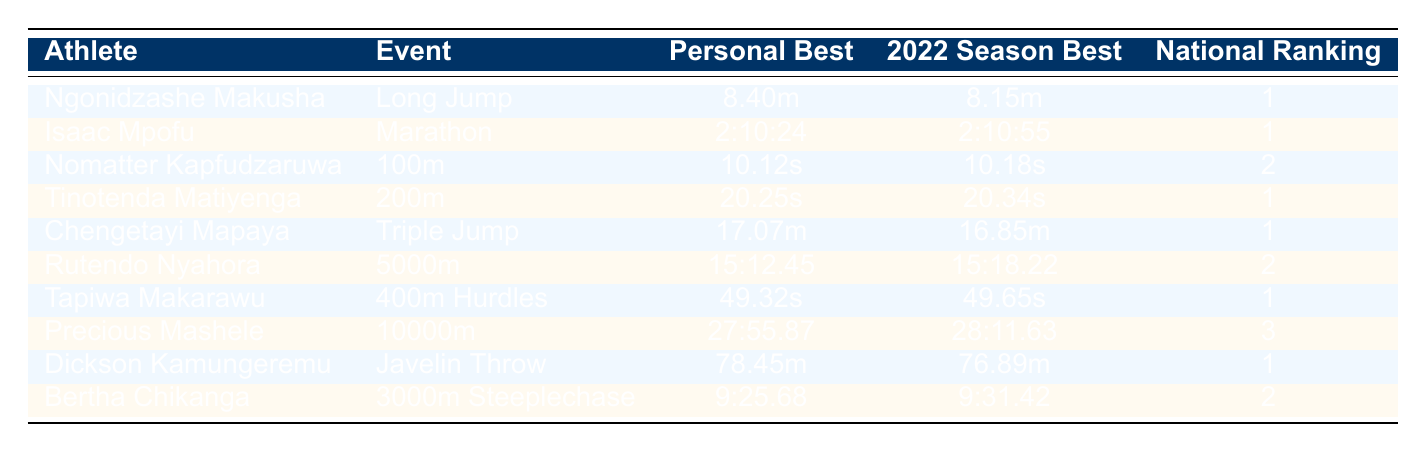What is the personal best for Ngonidzashe Makusha? The table shows that Ngonidzashe Makusha's personal best in Long Jump is 8.40m.
Answer: 8.40m Which athlete has the fastest 100m season best in 2022? According to the table, Nomatter Kapfudzaruwa has the fastest 100m season best of 10.18s.
Answer: Nomatter Kapfudzaruwa Is Dickson Kamungeremu ranked as the number one athlete in Javelin Throw? The table indicates that Dickson Kamungeremu is ranked number one in Javelin Throw, as indicated by the ranking column.
Answer: Yes What is the difference between the personal best and the 2022 season best for Isaac Mpofu? Isaac Mpofu's personal best is 2:10:24 and his 2022 season best is 2:10:55. To find the difference, we subtract: 2:10:55 - 2:10:24 = 0:00:31.
Answer: 0:00:31 Which event has the highest national ranking, and who is the athlete? The table shows multiple athletes ranked number one, including Ngonidzashe Makusha in Long Jump, Isaac Mpofu in Marathon, Tinotenda Matiyenga in 200m, Chengetayi Mapaya in Triple Jump, Tapiwa Makarawu in 400m Hurdles, and Dickson Kamungeremu in Javelin Throw. The events are Long Jump, Marathon, 200m, Triple Jump, 400m Hurdles, and Javelin Throw.
Answer: Long Jump, Ngonidzashe Makusha What is the average personal best across all athletes in the table? Calculating the average personal best involves converting the measurements to a common format (if needed). The total personal bests are 8.40m, 2:10:24, 10.12s, 20.25s, 17.07m, 15:12.45, 49.32s, 27:55.87, 78.45m, and 9:25.68. Since the events are different, we can’t compute an average directly. Thus, this question leads to no single average due to inconsistent units.
Answer: N/A Does Rutendo Nyahora have a season best of under 15:15 in the 5000m? The table shows Rutendo Nyahora's 2022 season best is 15:18.22, which is above 15:15.
Answer: No Which athlete has the best triple jump performance in 2022? Chengetayi Mapaya is indicated in the table with a personal best of 17.07m in Triple Jump, which is the highest among the athletes listed for that event.
Answer: Chengetayi Mapaya 